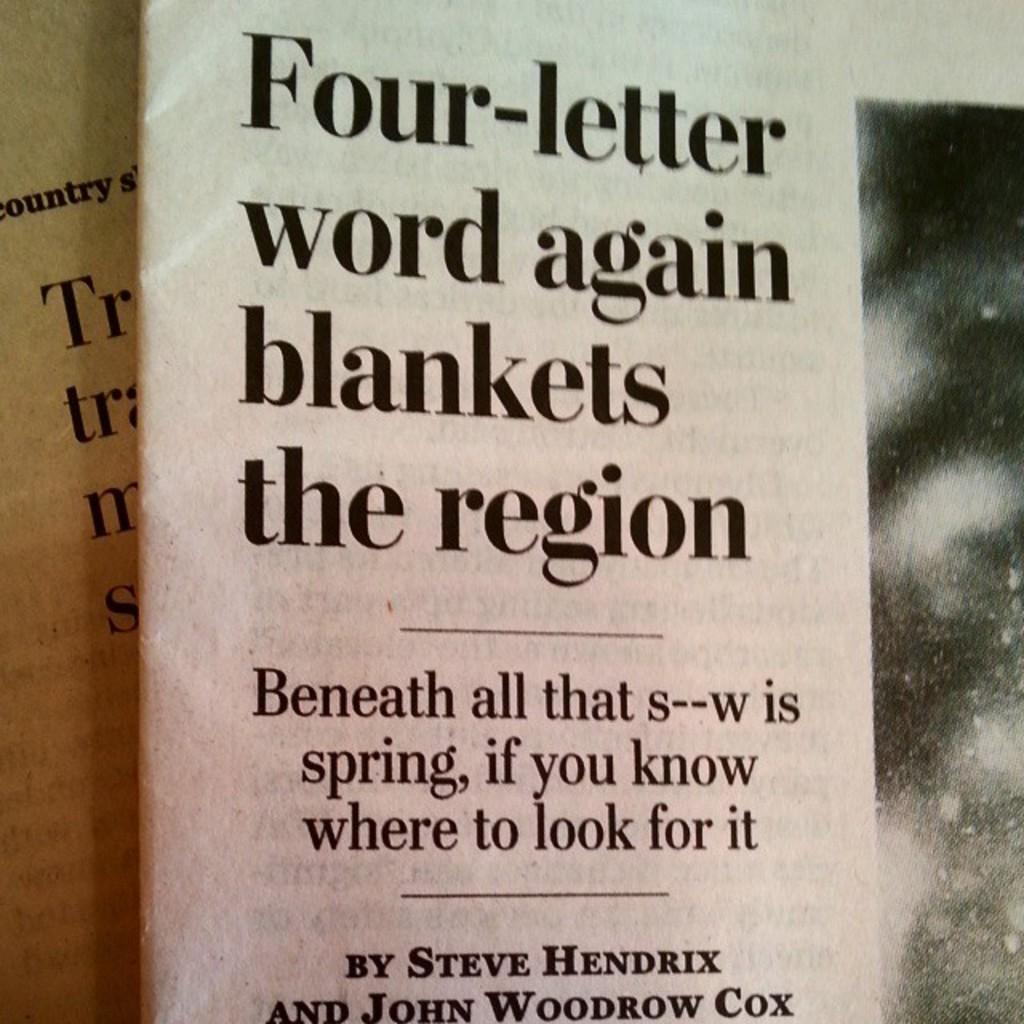<image>
Present a compact description of the photo's key features. An article with the heading, Four-Letter word again blankets the region 